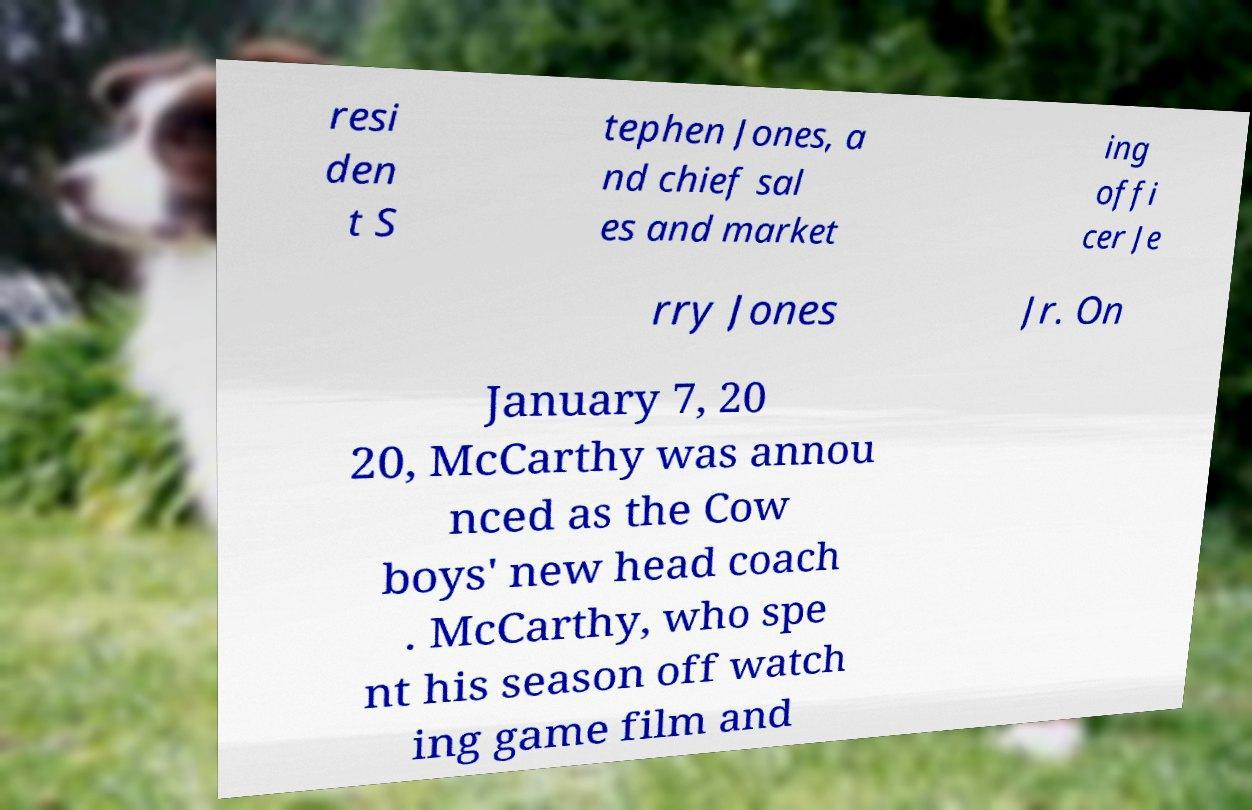Can you read and provide the text displayed in the image?This photo seems to have some interesting text. Can you extract and type it out for me? resi den t S tephen Jones, a nd chief sal es and market ing offi cer Je rry Jones Jr. On January 7, 20 20, McCarthy was annou nced as the Cow boys' new head coach . McCarthy, who spe nt his season off watch ing game film and 